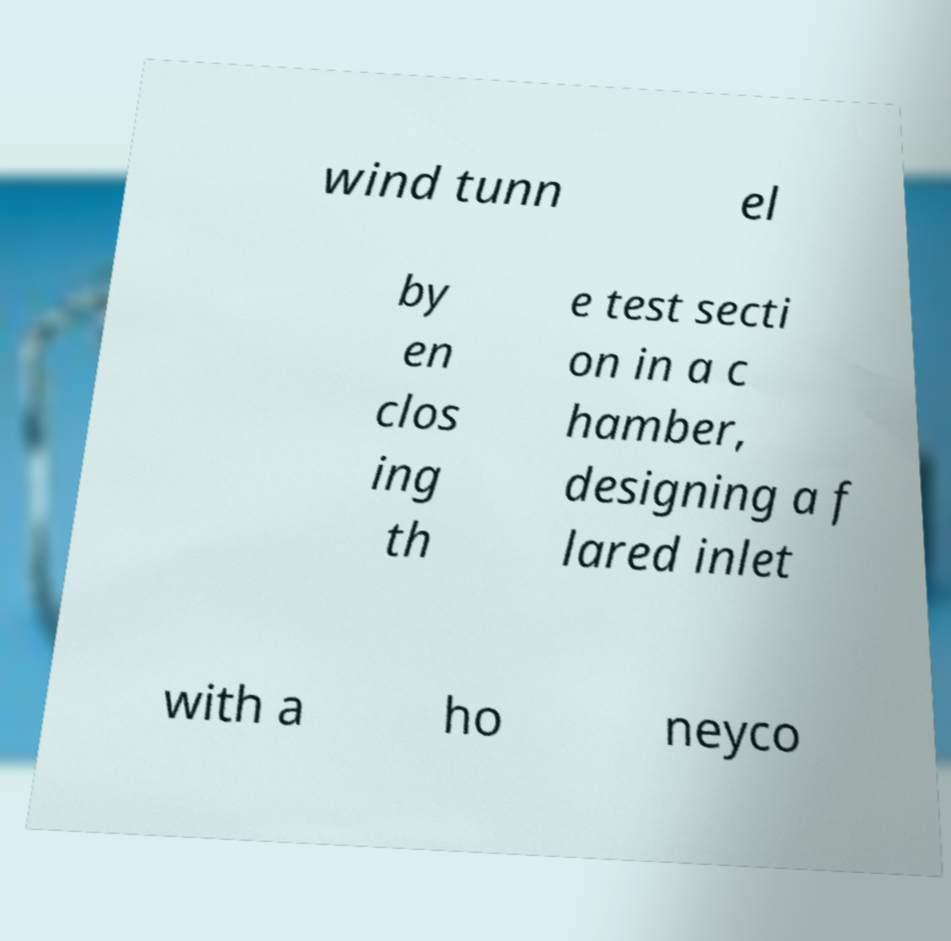There's text embedded in this image that I need extracted. Can you transcribe it verbatim? wind tunn el by en clos ing th e test secti on in a c hamber, designing a f lared inlet with a ho neyco 